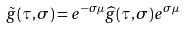<formula> <loc_0><loc_0><loc_500><loc_500>\tilde { g } ( \tau , \sigma ) = e ^ { - \sigma \mu } \widehat { g } ( \tau , \sigma ) e ^ { \sigma \mu }</formula> 